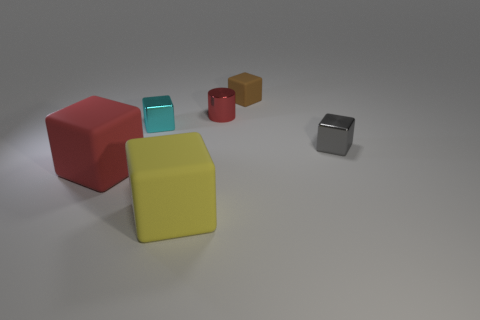Is the red thing that is in front of the red cylinder made of the same material as the small brown thing?
Provide a succinct answer. Yes. What color is the other big rubber thing that is the same shape as the yellow rubber thing?
Make the answer very short. Red. Are there any other things that have the same shape as the tiny red metallic object?
Give a very brief answer. No. Are there the same number of red rubber blocks behind the cyan metallic object and matte objects?
Ensure brevity in your answer.  No. Are there any big rubber cubes behind the red matte block?
Provide a short and direct response. No. How big is the red thing behind the large red rubber block on the left side of the small block that is on the right side of the small brown matte cube?
Your answer should be very brief. Small. Do the red object in front of the gray shiny thing and the large thing that is in front of the large red object have the same shape?
Give a very brief answer. Yes. The yellow object that is the same shape as the small gray metal object is what size?
Your response must be concise. Large. How many yellow objects have the same material as the cylinder?
Your answer should be very brief. 0. What is the tiny gray object made of?
Make the answer very short. Metal. 